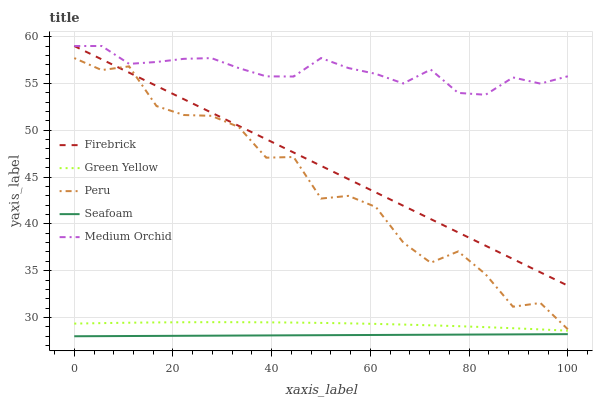Does Seafoam have the minimum area under the curve?
Answer yes or no. Yes. Does Medium Orchid have the maximum area under the curve?
Answer yes or no. Yes. Does Firebrick have the minimum area under the curve?
Answer yes or no. No. Does Firebrick have the maximum area under the curve?
Answer yes or no. No. Is Seafoam the smoothest?
Answer yes or no. Yes. Is Peru the roughest?
Answer yes or no. Yes. Is Firebrick the smoothest?
Answer yes or no. No. Is Firebrick the roughest?
Answer yes or no. No. Does Seafoam have the lowest value?
Answer yes or no. Yes. Does Firebrick have the lowest value?
Answer yes or no. No. Does Firebrick have the highest value?
Answer yes or no. Yes. Does Green Yellow have the highest value?
Answer yes or no. No. Is Seafoam less than Firebrick?
Answer yes or no. Yes. Is Medium Orchid greater than Peru?
Answer yes or no. Yes. Does Medium Orchid intersect Firebrick?
Answer yes or no. Yes. Is Medium Orchid less than Firebrick?
Answer yes or no. No. Is Medium Orchid greater than Firebrick?
Answer yes or no. No. Does Seafoam intersect Firebrick?
Answer yes or no. No. 